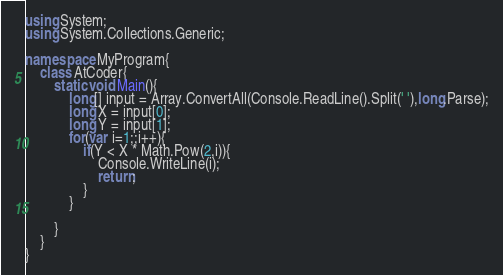Convert code to text. <code><loc_0><loc_0><loc_500><loc_500><_C#_>using System;
using System.Collections.Generic;

namespace MyProgram{
    class AtCoder{
        static void Main(){
            long[] input = Array.ConvertAll(Console.ReadLine().Split(' '),long.Parse);
            long X = input[0];
            long Y = input[1];
            for(var i=1;;i++){
                if(Y < X * Math.Pow(2,i)){
                    Console.WriteLine(i);
                    return;
                }
            }

        }
    } 
}</code> 